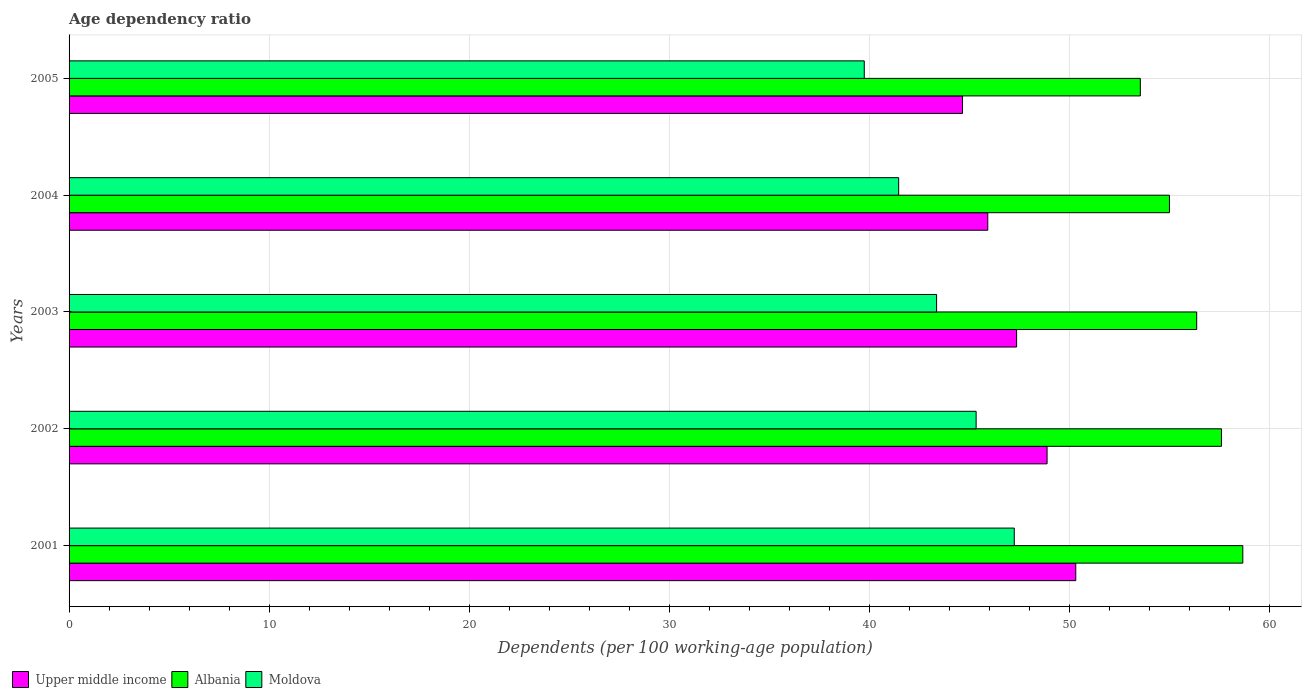Are the number of bars per tick equal to the number of legend labels?
Make the answer very short. Yes. How many bars are there on the 1st tick from the top?
Keep it short and to the point. 3. What is the age dependency ratio in in Upper middle income in 2005?
Give a very brief answer. 44.66. Across all years, what is the maximum age dependency ratio in in Moldova?
Your answer should be compact. 47.25. Across all years, what is the minimum age dependency ratio in in Albania?
Ensure brevity in your answer.  53.55. In which year was the age dependency ratio in in Moldova minimum?
Provide a succinct answer. 2005. What is the total age dependency ratio in in Moldova in the graph?
Keep it short and to the point. 217.16. What is the difference between the age dependency ratio in in Albania in 2002 and that in 2004?
Give a very brief answer. 2.6. What is the difference between the age dependency ratio in in Albania in 2005 and the age dependency ratio in in Moldova in 2001?
Your answer should be very brief. 6.3. What is the average age dependency ratio in in Moldova per year?
Your response must be concise. 43.43. In the year 2004, what is the difference between the age dependency ratio in in Moldova and age dependency ratio in in Upper middle income?
Make the answer very short. -4.45. In how many years, is the age dependency ratio in in Moldova greater than 56 %?
Ensure brevity in your answer.  0. What is the ratio of the age dependency ratio in in Upper middle income in 2001 to that in 2002?
Keep it short and to the point. 1.03. Is the age dependency ratio in in Upper middle income in 2001 less than that in 2004?
Your response must be concise. No. Is the difference between the age dependency ratio in in Moldova in 2001 and 2004 greater than the difference between the age dependency ratio in in Upper middle income in 2001 and 2004?
Provide a short and direct response. Yes. What is the difference between the highest and the second highest age dependency ratio in in Moldova?
Ensure brevity in your answer.  1.91. What is the difference between the highest and the lowest age dependency ratio in in Moldova?
Your response must be concise. 7.5. In how many years, is the age dependency ratio in in Moldova greater than the average age dependency ratio in in Moldova taken over all years?
Provide a short and direct response. 2. What does the 3rd bar from the top in 2003 represents?
Provide a short and direct response. Upper middle income. What does the 3rd bar from the bottom in 2005 represents?
Give a very brief answer. Moldova. Are all the bars in the graph horizontal?
Ensure brevity in your answer.  Yes. What is the difference between two consecutive major ticks on the X-axis?
Your response must be concise. 10. Does the graph contain grids?
Provide a succinct answer. Yes. Where does the legend appear in the graph?
Your answer should be compact. Bottom left. How are the legend labels stacked?
Make the answer very short. Horizontal. What is the title of the graph?
Provide a succinct answer. Age dependency ratio. What is the label or title of the X-axis?
Keep it short and to the point. Dependents (per 100 working-age population). What is the label or title of the Y-axis?
Ensure brevity in your answer.  Years. What is the Dependents (per 100 working-age population) of Upper middle income in 2001?
Your answer should be compact. 50.32. What is the Dependents (per 100 working-age population) of Albania in 2001?
Provide a short and direct response. 58.67. What is the Dependents (per 100 working-age population) in Moldova in 2001?
Provide a short and direct response. 47.25. What is the Dependents (per 100 working-age population) of Upper middle income in 2002?
Keep it short and to the point. 48.89. What is the Dependents (per 100 working-age population) in Albania in 2002?
Provide a short and direct response. 57.6. What is the Dependents (per 100 working-age population) of Moldova in 2002?
Make the answer very short. 45.34. What is the Dependents (per 100 working-age population) in Upper middle income in 2003?
Give a very brief answer. 47.36. What is the Dependents (per 100 working-age population) in Albania in 2003?
Your response must be concise. 56.36. What is the Dependents (per 100 working-age population) of Moldova in 2003?
Your answer should be compact. 43.36. What is the Dependents (per 100 working-age population) in Upper middle income in 2004?
Your response must be concise. 45.92. What is the Dependents (per 100 working-age population) of Albania in 2004?
Your answer should be very brief. 55. What is the Dependents (per 100 working-age population) of Moldova in 2004?
Offer a terse response. 41.47. What is the Dependents (per 100 working-age population) of Upper middle income in 2005?
Your answer should be very brief. 44.66. What is the Dependents (per 100 working-age population) in Albania in 2005?
Your answer should be very brief. 53.55. What is the Dependents (per 100 working-age population) of Moldova in 2005?
Your response must be concise. 39.75. Across all years, what is the maximum Dependents (per 100 working-age population) in Upper middle income?
Offer a very short reply. 50.32. Across all years, what is the maximum Dependents (per 100 working-age population) of Albania?
Provide a succinct answer. 58.67. Across all years, what is the maximum Dependents (per 100 working-age population) in Moldova?
Give a very brief answer. 47.25. Across all years, what is the minimum Dependents (per 100 working-age population) in Upper middle income?
Your response must be concise. 44.66. Across all years, what is the minimum Dependents (per 100 working-age population) in Albania?
Give a very brief answer. 53.55. Across all years, what is the minimum Dependents (per 100 working-age population) of Moldova?
Provide a short and direct response. 39.75. What is the total Dependents (per 100 working-age population) of Upper middle income in the graph?
Offer a very short reply. 237.15. What is the total Dependents (per 100 working-age population) of Albania in the graph?
Give a very brief answer. 281.18. What is the total Dependents (per 100 working-age population) of Moldova in the graph?
Keep it short and to the point. 217.16. What is the difference between the Dependents (per 100 working-age population) in Upper middle income in 2001 and that in 2002?
Your answer should be compact. 1.43. What is the difference between the Dependents (per 100 working-age population) in Albania in 2001 and that in 2002?
Provide a succinct answer. 1.07. What is the difference between the Dependents (per 100 working-age population) of Moldova in 2001 and that in 2002?
Keep it short and to the point. 1.91. What is the difference between the Dependents (per 100 working-age population) of Upper middle income in 2001 and that in 2003?
Provide a short and direct response. 2.96. What is the difference between the Dependents (per 100 working-age population) of Albania in 2001 and that in 2003?
Your answer should be very brief. 2.3. What is the difference between the Dependents (per 100 working-age population) in Moldova in 2001 and that in 2003?
Keep it short and to the point. 3.88. What is the difference between the Dependents (per 100 working-age population) of Upper middle income in 2001 and that in 2004?
Keep it short and to the point. 4.4. What is the difference between the Dependents (per 100 working-age population) of Albania in 2001 and that in 2004?
Give a very brief answer. 3.67. What is the difference between the Dependents (per 100 working-age population) of Moldova in 2001 and that in 2004?
Provide a succinct answer. 5.78. What is the difference between the Dependents (per 100 working-age population) in Upper middle income in 2001 and that in 2005?
Your response must be concise. 5.66. What is the difference between the Dependents (per 100 working-age population) in Albania in 2001 and that in 2005?
Offer a terse response. 5.12. What is the difference between the Dependents (per 100 working-age population) in Moldova in 2001 and that in 2005?
Make the answer very short. 7.5. What is the difference between the Dependents (per 100 working-age population) in Upper middle income in 2002 and that in 2003?
Keep it short and to the point. 1.52. What is the difference between the Dependents (per 100 working-age population) of Albania in 2002 and that in 2003?
Offer a terse response. 1.24. What is the difference between the Dependents (per 100 working-age population) of Moldova in 2002 and that in 2003?
Make the answer very short. 1.98. What is the difference between the Dependents (per 100 working-age population) of Upper middle income in 2002 and that in 2004?
Your answer should be compact. 2.96. What is the difference between the Dependents (per 100 working-age population) of Albania in 2002 and that in 2004?
Provide a short and direct response. 2.6. What is the difference between the Dependents (per 100 working-age population) in Moldova in 2002 and that in 2004?
Provide a succinct answer. 3.87. What is the difference between the Dependents (per 100 working-age population) in Upper middle income in 2002 and that in 2005?
Your answer should be very brief. 4.23. What is the difference between the Dependents (per 100 working-age population) in Albania in 2002 and that in 2005?
Ensure brevity in your answer.  4.05. What is the difference between the Dependents (per 100 working-age population) of Moldova in 2002 and that in 2005?
Provide a succinct answer. 5.59. What is the difference between the Dependents (per 100 working-age population) in Upper middle income in 2003 and that in 2004?
Offer a terse response. 1.44. What is the difference between the Dependents (per 100 working-age population) in Albania in 2003 and that in 2004?
Make the answer very short. 1.36. What is the difference between the Dependents (per 100 working-age population) of Moldova in 2003 and that in 2004?
Provide a succinct answer. 1.89. What is the difference between the Dependents (per 100 working-age population) in Upper middle income in 2003 and that in 2005?
Your response must be concise. 2.7. What is the difference between the Dependents (per 100 working-age population) in Albania in 2003 and that in 2005?
Give a very brief answer. 2.82. What is the difference between the Dependents (per 100 working-age population) of Moldova in 2003 and that in 2005?
Keep it short and to the point. 3.62. What is the difference between the Dependents (per 100 working-age population) of Upper middle income in 2004 and that in 2005?
Give a very brief answer. 1.26. What is the difference between the Dependents (per 100 working-age population) in Albania in 2004 and that in 2005?
Your response must be concise. 1.45. What is the difference between the Dependents (per 100 working-age population) of Moldova in 2004 and that in 2005?
Give a very brief answer. 1.72. What is the difference between the Dependents (per 100 working-age population) of Upper middle income in 2001 and the Dependents (per 100 working-age population) of Albania in 2002?
Your answer should be compact. -7.28. What is the difference between the Dependents (per 100 working-age population) of Upper middle income in 2001 and the Dependents (per 100 working-age population) of Moldova in 2002?
Your answer should be very brief. 4.98. What is the difference between the Dependents (per 100 working-age population) of Albania in 2001 and the Dependents (per 100 working-age population) of Moldova in 2002?
Your response must be concise. 13.33. What is the difference between the Dependents (per 100 working-age population) of Upper middle income in 2001 and the Dependents (per 100 working-age population) of Albania in 2003?
Make the answer very short. -6.04. What is the difference between the Dependents (per 100 working-age population) in Upper middle income in 2001 and the Dependents (per 100 working-age population) in Moldova in 2003?
Make the answer very short. 6.96. What is the difference between the Dependents (per 100 working-age population) in Albania in 2001 and the Dependents (per 100 working-age population) in Moldova in 2003?
Your response must be concise. 15.31. What is the difference between the Dependents (per 100 working-age population) in Upper middle income in 2001 and the Dependents (per 100 working-age population) in Albania in 2004?
Your answer should be compact. -4.68. What is the difference between the Dependents (per 100 working-age population) in Upper middle income in 2001 and the Dependents (per 100 working-age population) in Moldova in 2004?
Your response must be concise. 8.85. What is the difference between the Dependents (per 100 working-age population) of Albania in 2001 and the Dependents (per 100 working-age population) of Moldova in 2004?
Offer a terse response. 17.2. What is the difference between the Dependents (per 100 working-age population) of Upper middle income in 2001 and the Dependents (per 100 working-age population) of Albania in 2005?
Your answer should be compact. -3.23. What is the difference between the Dependents (per 100 working-age population) in Upper middle income in 2001 and the Dependents (per 100 working-age population) in Moldova in 2005?
Make the answer very short. 10.57. What is the difference between the Dependents (per 100 working-age population) in Albania in 2001 and the Dependents (per 100 working-age population) in Moldova in 2005?
Keep it short and to the point. 18.92. What is the difference between the Dependents (per 100 working-age population) of Upper middle income in 2002 and the Dependents (per 100 working-age population) of Albania in 2003?
Offer a very short reply. -7.48. What is the difference between the Dependents (per 100 working-age population) of Upper middle income in 2002 and the Dependents (per 100 working-age population) of Moldova in 2003?
Give a very brief answer. 5.52. What is the difference between the Dependents (per 100 working-age population) in Albania in 2002 and the Dependents (per 100 working-age population) in Moldova in 2003?
Ensure brevity in your answer.  14.24. What is the difference between the Dependents (per 100 working-age population) of Upper middle income in 2002 and the Dependents (per 100 working-age population) of Albania in 2004?
Provide a succinct answer. -6.12. What is the difference between the Dependents (per 100 working-age population) in Upper middle income in 2002 and the Dependents (per 100 working-age population) in Moldova in 2004?
Offer a terse response. 7.42. What is the difference between the Dependents (per 100 working-age population) in Albania in 2002 and the Dependents (per 100 working-age population) in Moldova in 2004?
Make the answer very short. 16.13. What is the difference between the Dependents (per 100 working-age population) in Upper middle income in 2002 and the Dependents (per 100 working-age population) in Albania in 2005?
Offer a very short reply. -4.66. What is the difference between the Dependents (per 100 working-age population) of Upper middle income in 2002 and the Dependents (per 100 working-age population) of Moldova in 2005?
Provide a succinct answer. 9.14. What is the difference between the Dependents (per 100 working-age population) of Albania in 2002 and the Dependents (per 100 working-age population) of Moldova in 2005?
Provide a short and direct response. 17.85. What is the difference between the Dependents (per 100 working-age population) of Upper middle income in 2003 and the Dependents (per 100 working-age population) of Albania in 2004?
Offer a terse response. -7.64. What is the difference between the Dependents (per 100 working-age population) in Upper middle income in 2003 and the Dependents (per 100 working-age population) in Moldova in 2004?
Provide a short and direct response. 5.89. What is the difference between the Dependents (per 100 working-age population) of Albania in 2003 and the Dependents (per 100 working-age population) of Moldova in 2004?
Provide a short and direct response. 14.9. What is the difference between the Dependents (per 100 working-age population) in Upper middle income in 2003 and the Dependents (per 100 working-age population) in Albania in 2005?
Your answer should be compact. -6.18. What is the difference between the Dependents (per 100 working-age population) in Upper middle income in 2003 and the Dependents (per 100 working-age population) in Moldova in 2005?
Give a very brief answer. 7.61. What is the difference between the Dependents (per 100 working-age population) in Albania in 2003 and the Dependents (per 100 working-age population) in Moldova in 2005?
Your answer should be compact. 16.62. What is the difference between the Dependents (per 100 working-age population) in Upper middle income in 2004 and the Dependents (per 100 working-age population) in Albania in 2005?
Your response must be concise. -7.62. What is the difference between the Dependents (per 100 working-age population) of Upper middle income in 2004 and the Dependents (per 100 working-age population) of Moldova in 2005?
Provide a short and direct response. 6.17. What is the difference between the Dependents (per 100 working-age population) of Albania in 2004 and the Dependents (per 100 working-age population) of Moldova in 2005?
Your answer should be compact. 15.25. What is the average Dependents (per 100 working-age population) of Upper middle income per year?
Ensure brevity in your answer.  47.43. What is the average Dependents (per 100 working-age population) in Albania per year?
Provide a short and direct response. 56.24. What is the average Dependents (per 100 working-age population) in Moldova per year?
Your response must be concise. 43.43. In the year 2001, what is the difference between the Dependents (per 100 working-age population) of Upper middle income and Dependents (per 100 working-age population) of Albania?
Provide a succinct answer. -8.35. In the year 2001, what is the difference between the Dependents (per 100 working-age population) of Upper middle income and Dependents (per 100 working-age population) of Moldova?
Your answer should be very brief. 3.07. In the year 2001, what is the difference between the Dependents (per 100 working-age population) of Albania and Dependents (per 100 working-age population) of Moldova?
Provide a short and direct response. 11.42. In the year 2002, what is the difference between the Dependents (per 100 working-age population) of Upper middle income and Dependents (per 100 working-age population) of Albania?
Your response must be concise. -8.72. In the year 2002, what is the difference between the Dependents (per 100 working-age population) in Upper middle income and Dependents (per 100 working-age population) in Moldova?
Offer a terse response. 3.55. In the year 2002, what is the difference between the Dependents (per 100 working-age population) of Albania and Dependents (per 100 working-age population) of Moldova?
Give a very brief answer. 12.26. In the year 2003, what is the difference between the Dependents (per 100 working-age population) in Upper middle income and Dependents (per 100 working-age population) in Albania?
Your response must be concise. -9. In the year 2003, what is the difference between the Dependents (per 100 working-age population) of Upper middle income and Dependents (per 100 working-age population) of Moldova?
Offer a very short reply. 4. In the year 2003, what is the difference between the Dependents (per 100 working-age population) in Albania and Dependents (per 100 working-age population) in Moldova?
Provide a succinct answer. 13. In the year 2004, what is the difference between the Dependents (per 100 working-age population) in Upper middle income and Dependents (per 100 working-age population) in Albania?
Keep it short and to the point. -9.08. In the year 2004, what is the difference between the Dependents (per 100 working-age population) in Upper middle income and Dependents (per 100 working-age population) in Moldova?
Make the answer very short. 4.45. In the year 2004, what is the difference between the Dependents (per 100 working-age population) in Albania and Dependents (per 100 working-age population) in Moldova?
Offer a very short reply. 13.53. In the year 2005, what is the difference between the Dependents (per 100 working-age population) in Upper middle income and Dependents (per 100 working-age population) in Albania?
Your response must be concise. -8.89. In the year 2005, what is the difference between the Dependents (per 100 working-age population) of Upper middle income and Dependents (per 100 working-age population) of Moldova?
Provide a short and direct response. 4.91. In the year 2005, what is the difference between the Dependents (per 100 working-age population) in Albania and Dependents (per 100 working-age population) in Moldova?
Give a very brief answer. 13.8. What is the ratio of the Dependents (per 100 working-age population) in Upper middle income in 2001 to that in 2002?
Provide a short and direct response. 1.03. What is the ratio of the Dependents (per 100 working-age population) in Albania in 2001 to that in 2002?
Make the answer very short. 1.02. What is the ratio of the Dependents (per 100 working-age population) in Moldova in 2001 to that in 2002?
Offer a terse response. 1.04. What is the ratio of the Dependents (per 100 working-age population) in Upper middle income in 2001 to that in 2003?
Your answer should be very brief. 1.06. What is the ratio of the Dependents (per 100 working-age population) in Albania in 2001 to that in 2003?
Ensure brevity in your answer.  1.04. What is the ratio of the Dependents (per 100 working-age population) of Moldova in 2001 to that in 2003?
Keep it short and to the point. 1.09. What is the ratio of the Dependents (per 100 working-age population) in Upper middle income in 2001 to that in 2004?
Provide a succinct answer. 1.1. What is the ratio of the Dependents (per 100 working-age population) in Albania in 2001 to that in 2004?
Your response must be concise. 1.07. What is the ratio of the Dependents (per 100 working-age population) in Moldova in 2001 to that in 2004?
Give a very brief answer. 1.14. What is the ratio of the Dependents (per 100 working-age population) in Upper middle income in 2001 to that in 2005?
Make the answer very short. 1.13. What is the ratio of the Dependents (per 100 working-age population) of Albania in 2001 to that in 2005?
Provide a succinct answer. 1.1. What is the ratio of the Dependents (per 100 working-age population) in Moldova in 2001 to that in 2005?
Offer a very short reply. 1.19. What is the ratio of the Dependents (per 100 working-age population) in Upper middle income in 2002 to that in 2003?
Your answer should be compact. 1.03. What is the ratio of the Dependents (per 100 working-age population) of Albania in 2002 to that in 2003?
Provide a succinct answer. 1.02. What is the ratio of the Dependents (per 100 working-age population) of Moldova in 2002 to that in 2003?
Make the answer very short. 1.05. What is the ratio of the Dependents (per 100 working-age population) in Upper middle income in 2002 to that in 2004?
Your answer should be very brief. 1.06. What is the ratio of the Dependents (per 100 working-age population) of Albania in 2002 to that in 2004?
Ensure brevity in your answer.  1.05. What is the ratio of the Dependents (per 100 working-age population) of Moldova in 2002 to that in 2004?
Offer a very short reply. 1.09. What is the ratio of the Dependents (per 100 working-age population) in Upper middle income in 2002 to that in 2005?
Your response must be concise. 1.09. What is the ratio of the Dependents (per 100 working-age population) of Albania in 2002 to that in 2005?
Your answer should be compact. 1.08. What is the ratio of the Dependents (per 100 working-age population) of Moldova in 2002 to that in 2005?
Your response must be concise. 1.14. What is the ratio of the Dependents (per 100 working-age population) in Upper middle income in 2003 to that in 2004?
Your response must be concise. 1.03. What is the ratio of the Dependents (per 100 working-age population) in Albania in 2003 to that in 2004?
Keep it short and to the point. 1.02. What is the ratio of the Dependents (per 100 working-age population) of Moldova in 2003 to that in 2004?
Your response must be concise. 1.05. What is the ratio of the Dependents (per 100 working-age population) of Upper middle income in 2003 to that in 2005?
Make the answer very short. 1.06. What is the ratio of the Dependents (per 100 working-age population) of Albania in 2003 to that in 2005?
Give a very brief answer. 1.05. What is the ratio of the Dependents (per 100 working-age population) of Moldova in 2003 to that in 2005?
Provide a succinct answer. 1.09. What is the ratio of the Dependents (per 100 working-age population) in Upper middle income in 2004 to that in 2005?
Offer a terse response. 1.03. What is the ratio of the Dependents (per 100 working-age population) of Albania in 2004 to that in 2005?
Offer a very short reply. 1.03. What is the ratio of the Dependents (per 100 working-age population) of Moldova in 2004 to that in 2005?
Give a very brief answer. 1.04. What is the difference between the highest and the second highest Dependents (per 100 working-age population) in Upper middle income?
Your answer should be very brief. 1.43. What is the difference between the highest and the second highest Dependents (per 100 working-age population) in Albania?
Provide a succinct answer. 1.07. What is the difference between the highest and the second highest Dependents (per 100 working-age population) of Moldova?
Keep it short and to the point. 1.91. What is the difference between the highest and the lowest Dependents (per 100 working-age population) of Upper middle income?
Offer a terse response. 5.66. What is the difference between the highest and the lowest Dependents (per 100 working-age population) of Albania?
Give a very brief answer. 5.12. What is the difference between the highest and the lowest Dependents (per 100 working-age population) in Moldova?
Give a very brief answer. 7.5. 